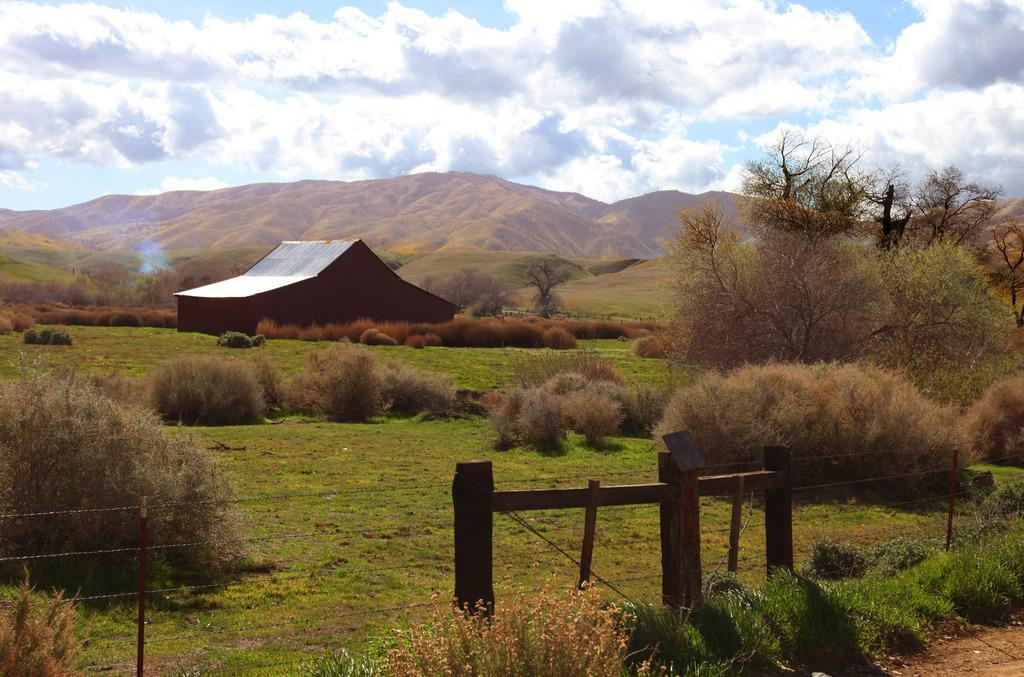What type of structure is visible in the image? There is a house in the image. What type of vegetation can be seen in the image? There is a group of plants, grass, and trees in the image. What type of support structures are present in the image? There are wooden poles and a fence in the image. What can be seen in the background of the image? Mountains and the sky are visible in the background of the image. What is the condition of the sky in the image? The sky appears cloudy in the image. What type of blade is being used to cut the grass in the image? There is no blade visible in the image; it is not mentioned that the grass is being cut. 